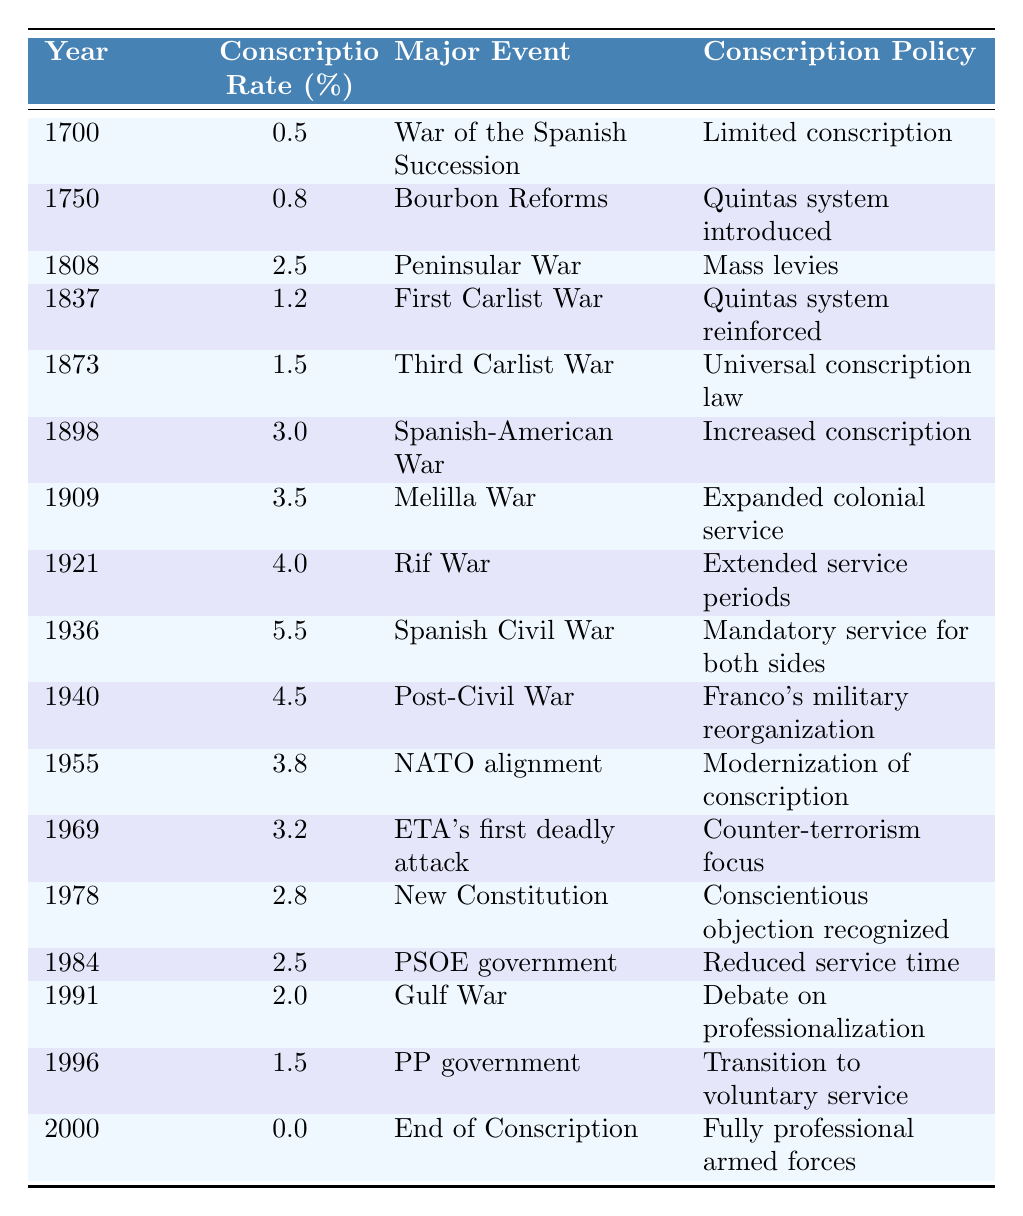What year saw the highest conscription rate in Spain? The table shows the conscription rate over the years, with the highest value being 5.5%, which occurred in 1936 during the Spanish Civil War.
Answer: 1936 What was the conscription rate in 1873? Referring to the table, the conscription rate in 1873 was 1.5%, during the time of the Third Carlist War.
Answer: 1.5% Did the conscription rate increase from 1898 to 1909? By comparing the values in the table, the conscription rate was 3.0% in 1898 and increased to 3.5% in 1909. Thus, it did increase during that period.
Answer: Yes What major event corresponds with the introduction of the universal conscription law? Looking at the table, the universal conscription law was introduced in 1873, which corresponds with the Third Carlist War.
Answer: Third Carlist War What was the difference in conscription rates between 1940 and 1955? The conscription rates were 4.5% in 1940 and 3.8% in 1955. The difference is 4.5% - 3.8% = 0.7%.
Answer: 0.7% In which year did Spain recognize conscientious objection? The table indicates that conscientious objection was recognized in 1978 as part of the New Constitution.
Answer: 1978 What was the trend in conscription policy from the year 2000 compared to previous years? The table shows that by 2000, conscription ended with the establishment of fully professional armed forces, indicating a significant shift from mandatory service to a professional military.
Answer: Shift to professional military What is the average conscription rate from 1808 to 1936? The rates for those years are: 2.5% (1808), 1.2% (1837), 1.5% (1873), 3.0% (1898), 3.5% (1909), 4.0% (1921), and 5.5% (1936). Summing these gives 2.5 + 1.2 + 1.5 + 3.0 + 3.5 + 4.0 + 5.5 = 21.2, and dividing by 7 yields an average of approximately 3.0%.
Answer: 3.0% Which conscription policy was in place during the Melilla War? According to the table, during the Melilla War in 1909, the conscription policy was expanded colonial service.
Answer: Expanded colonial service How many years had mandatory service been in effect by 1940? From 1936 (start of mandatory service) to 1940 is 4 years. Thus, mandatory service had been in effect for 4 years by then.
Answer: 4 years 